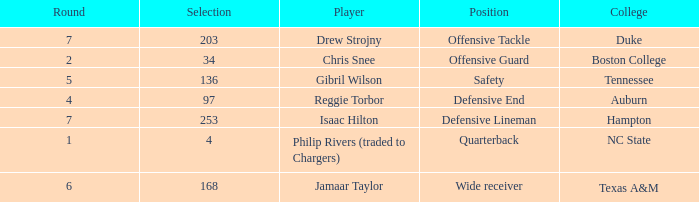Which Position has a Player of gibril wilson? Safety. 